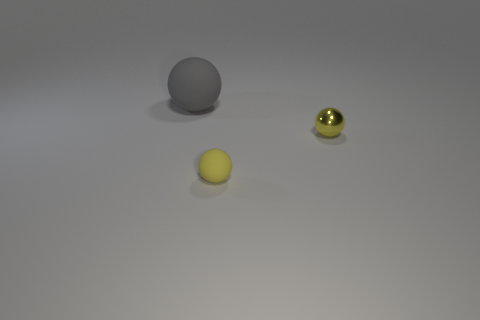Subtract all small yellow rubber spheres. How many spheres are left? 2 Add 3 metal things. How many objects exist? 6 Subtract all large red cylinders. Subtract all yellow rubber spheres. How many objects are left? 2 Add 1 yellow balls. How many yellow balls are left? 3 Add 2 spheres. How many spheres exist? 5 Subtract all yellow spheres. How many spheres are left? 1 Subtract 0 brown blocks. How many objects are left? 3 Subtract 3 balls. How many balls are left? 0 Subtract all yellow spheres. Subtract all yellow blocks. How many spheres are left? 1 Subtract all yellow cylinders. How many yellow spheres are left? 2 